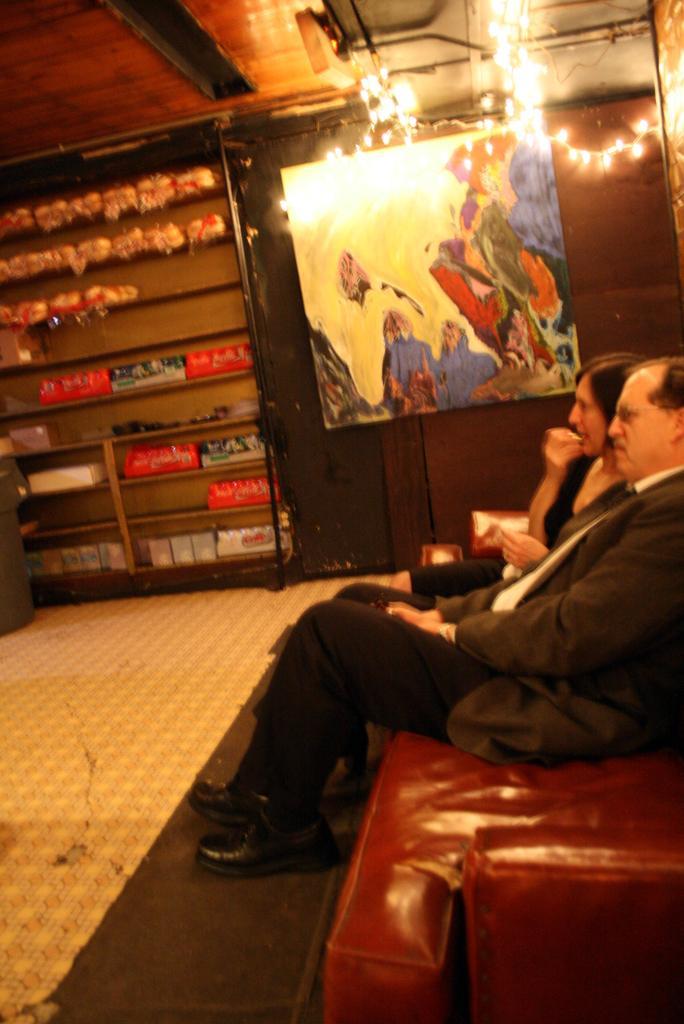Please provide a concise description of this image. On the right side of the image we can see persons sitting on the sofa. In the center of the image there is a painting. On the left side of the image we can see objects, books and gifts arranged in a shelves. At the top of the image we can see a lighting. 